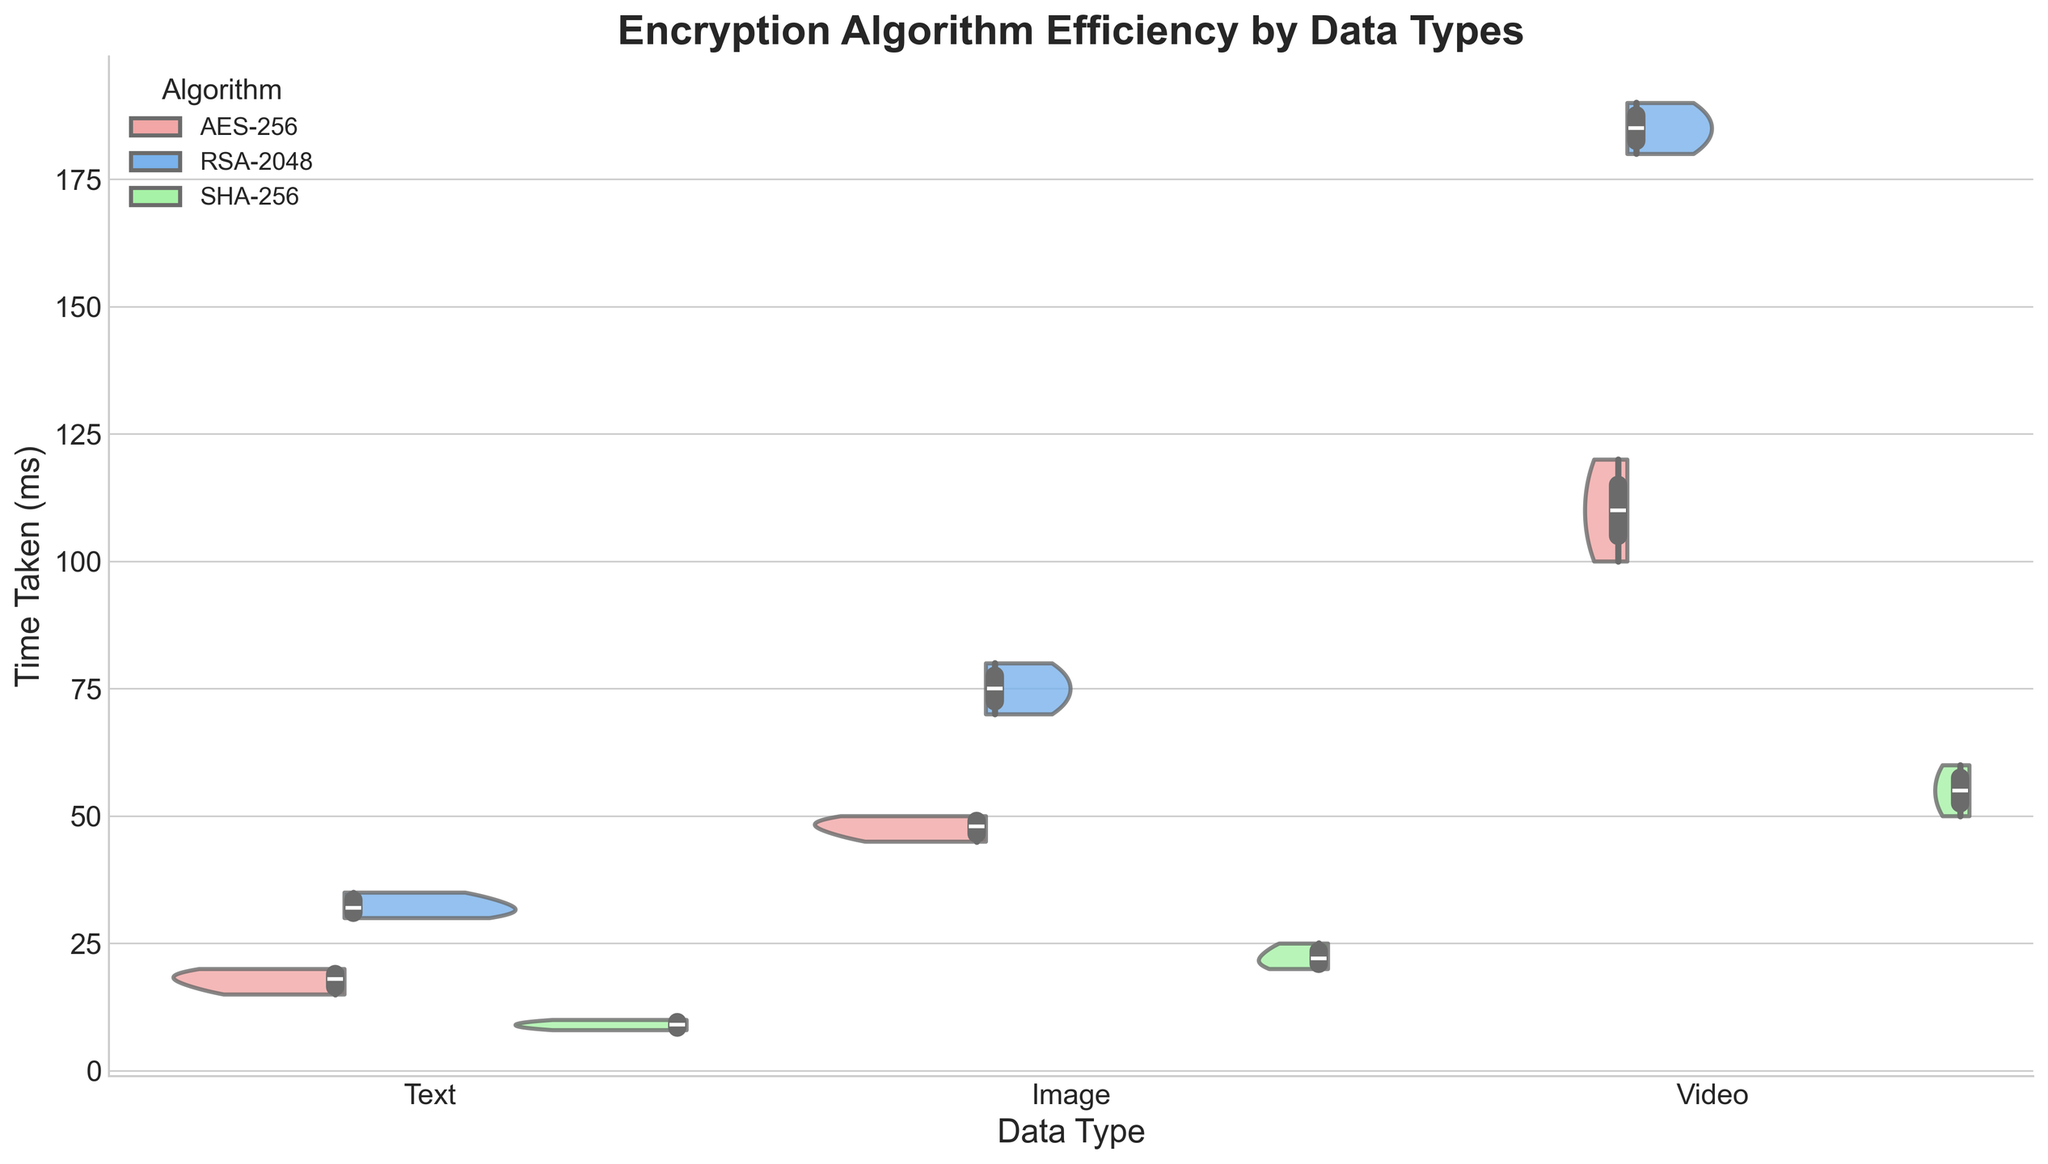What's the title of the figure? The title is usually located at the top of the figure. In this case, we know the title from the code provided.
Answer: Encryption Algorithm Efficiency by Data Types Which algorithms are compared in the figure? The figure uses different colors to represent each algorithm. Here, the colors are mapped to "AES-256", "RSA-2048", and "SHA-256".
Answer: AES-256, RSA-2048, SHA-256 What are the time measurements taken for each data type? The y-axis of the figure represents the time taken in milliseconds (ms). By examining the violin shapes for each data type, we can infer the time ranges.
Answer: In milliseconds, as shown on the y-axis Which data type appears to have the highest variability in encryption time using RSA-2048? Variability can be inferred from the width and spread of the violin plot. For RSA-2048, look for the data type with the widest and most spread-out violin representation.
Answer: Video Which algorithm has the lowest median time for encrypting text data? The box plot within the violin plot indicates the median time. Find the median line within each violin representation for text data.
Answer: SHA-256 Is there a significant difference in encryption times between AES-256 and RSA-2048 for image data? By comparing the violin plots for AES-256 and RSA-2048 under the image data type category, note the position and spread of the two plots.
Answer: Yes Which data type has the most consistent encryption times across all algorithms? Consistency can be observed through the narrow violin plots with minimal spread. Examine all data types and algorithms for this characteristic.
Answer: Text What is the approximate range of time taken for the AES-256 algorithm for video data? The range can be observed from the top to the bottom of the violin plot. For AES-256 under video, estimate this range.
Answer: 100-120 ms How does the memory usage for RSA-2048 algorithm compare across text, image, and video data types? Although not shown in the plot, the comparison can be inferred from the dataset or by deducing the correlation with the encryption time and data types.
Answer: Higher for video, followed by image, then text Does SHA-256 have a wider spread in encryption times for image or video data? By comparing the widths of the violins for SHA-256 under image and video data, determine which one is wider.
Answer: Video 